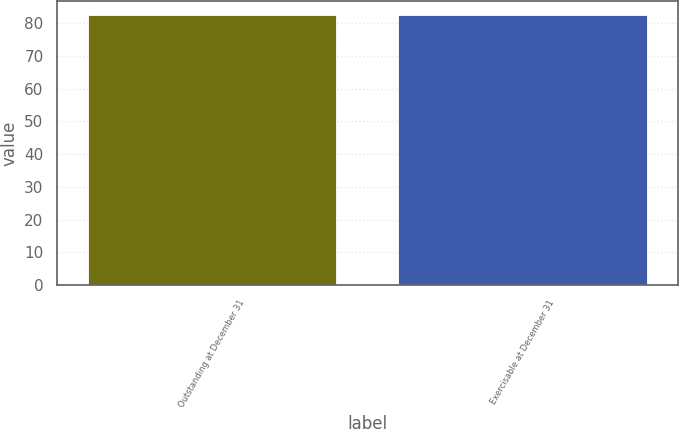<chart> <loc_0><loc_0><loc_500><loc_500><bar_chart><fcel>Outstanding at December 31<fcel>Exercisable at December 31<nl><fcel>82.43<fcel>82.53<nl></chart> 